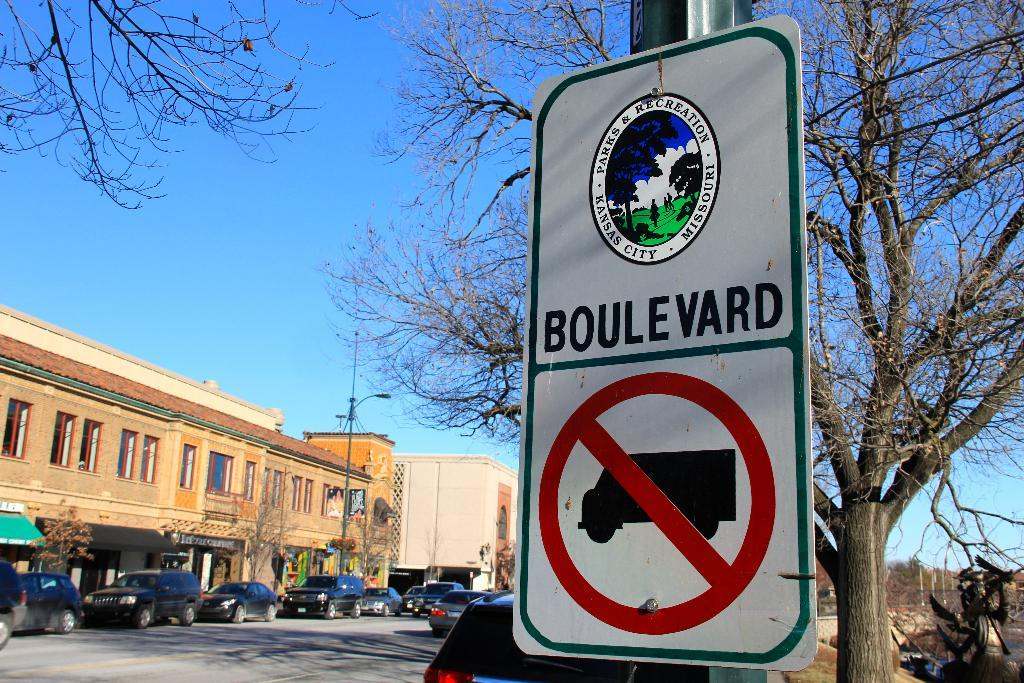<image>
Share a concise interpretation of the image provided. The no trucks sign has a sticker above from the Parks & Recreation of Kansas City, Missouri. 